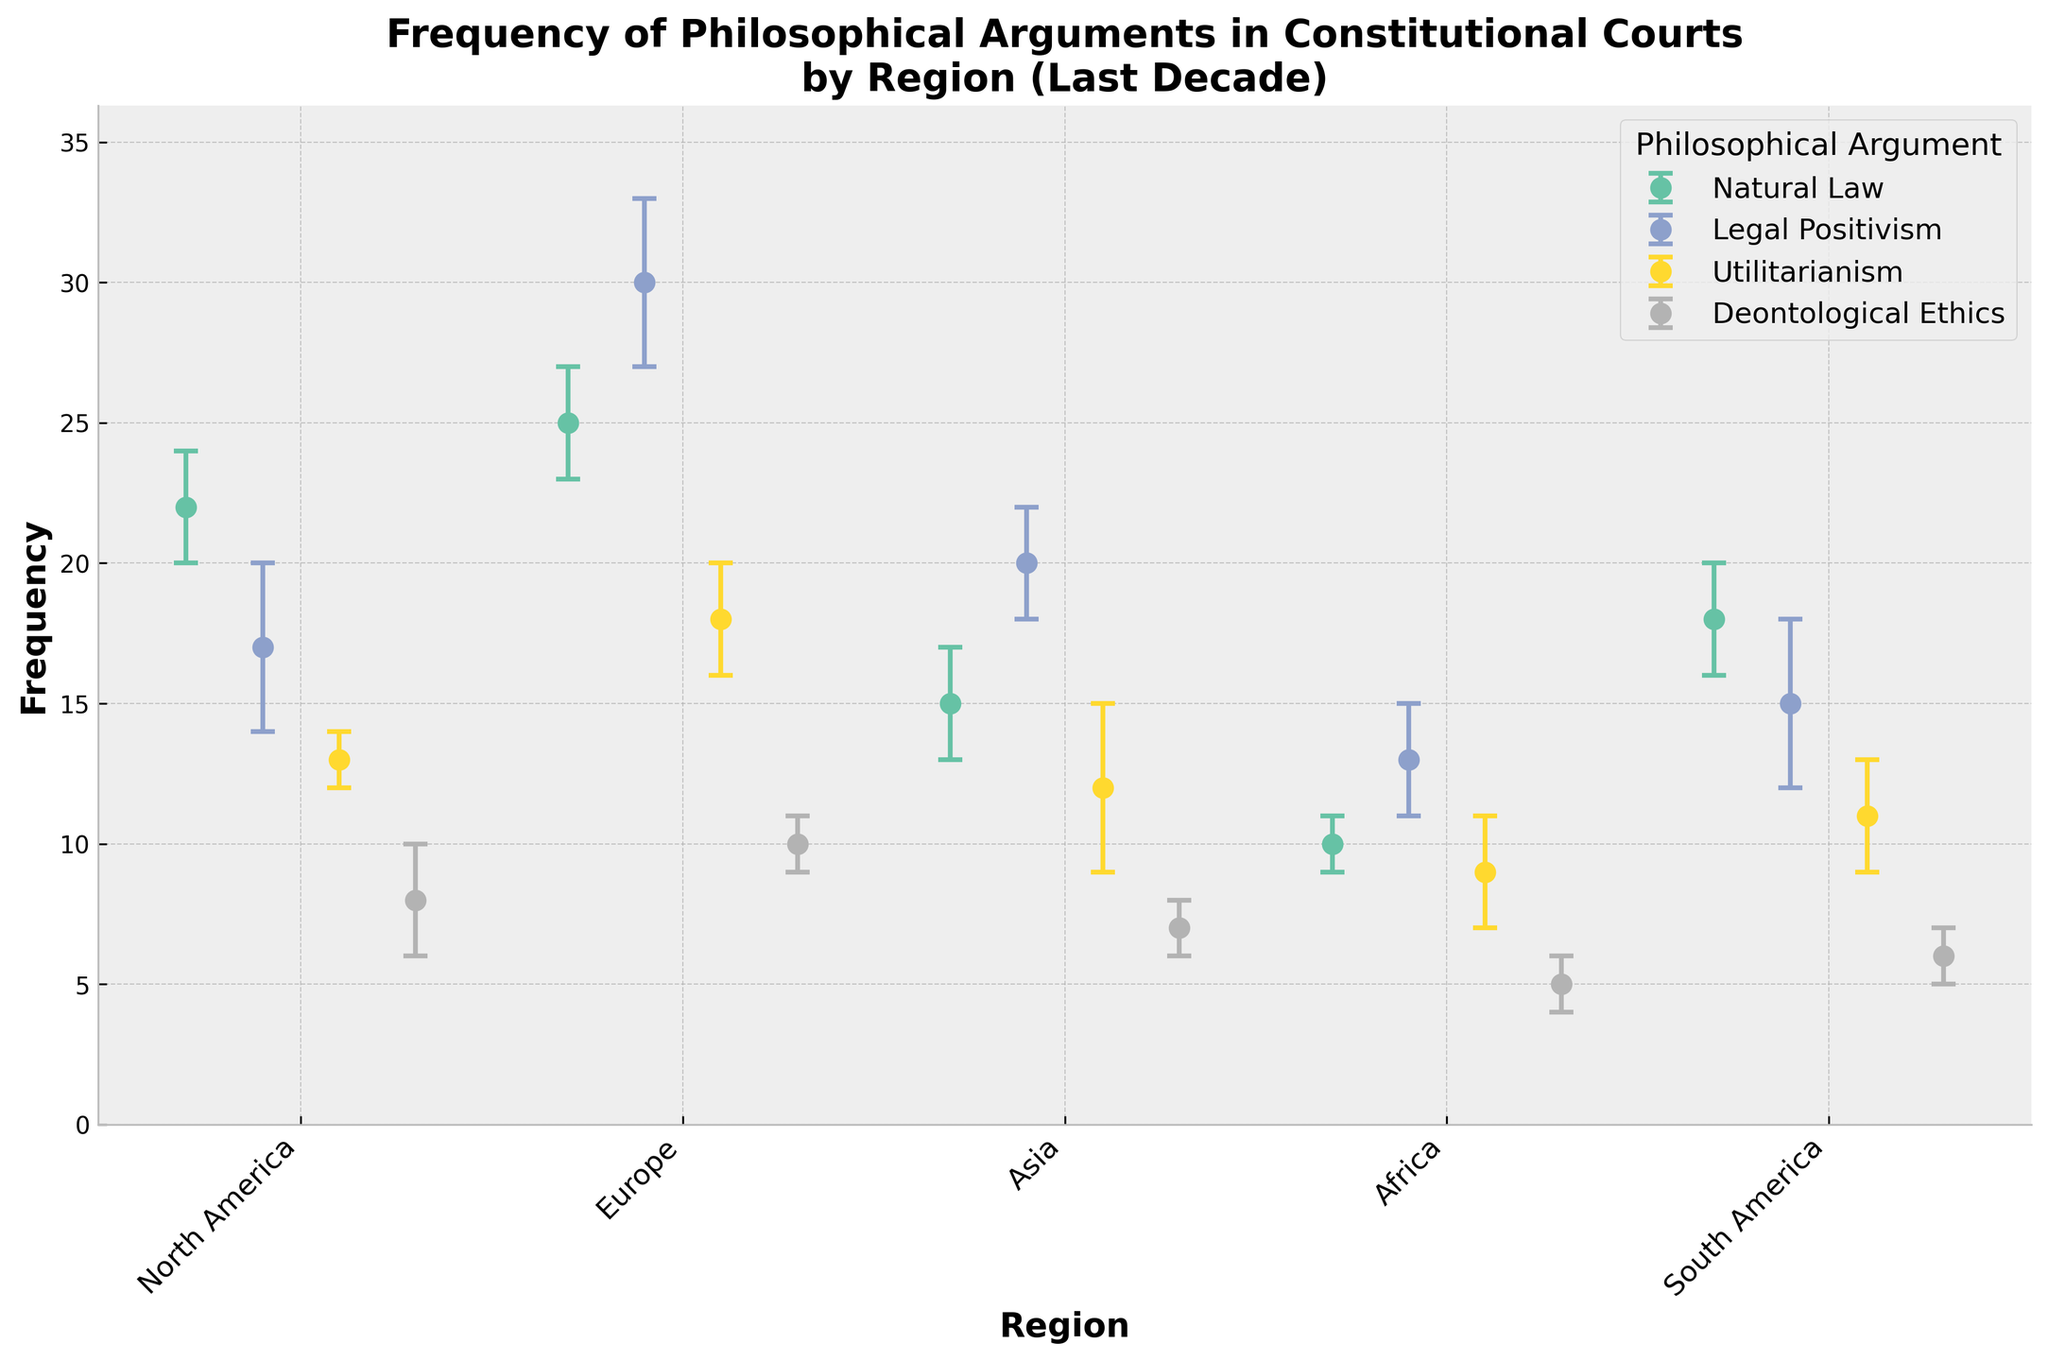What is the title of the figure? At the top of the figure, there is a text that summarizes the content of the plot. The title is "Frequency of Philosophical Arguments in Constitutional Courts by Region (Last Decade)."
Answer: Frequency of Philosophical Arguments in Constitutional Courts by Region (Last Decade) Which philosophical argument is most frequently used in Europe? By observing the height of the dots for Europe, the argument with the highest frequency value is identified. "Legal Positivism" has the highest frequency value among other arguments in Europe.
Answer: Legal Positivism What is the frequency of Utilitarianism in North America? By locating the dot for Utilitarianism in the region of North America, the associated frequency value is read off from the plot. The frequency of Utilitarianism in North America is indicated by dot placement at 13.
Answer: 13 Which region has the least frequency of Deontological Ethics? By examining the dots for Deontological Ethics across all regions, the region with the lowest dot is identified. The dot for Deontological Ethics in Africa is the lowest, indicating a frequency of 5.
Answer: Africa What is the total frequency of Legal Positivism across all regions? Sum the frequency values for Legal Positivism in each region: North America (17) + Europe (30) + Asia (20) + Africa (13) + South America (15). The total frequency is calculated as 95.
Answer: 95 Compare the frequency of Natural Law between North America and South America. Which region has a higher frequency? By looking at the dots for Natural Law in both North America (22) and South America (18), the higher of the two values is identified. North America's dot is positioned higher, indicating a higher frequency.
Answer: North America What is the average error margin for Utilitarianism across all regions? Add the error margins for Utilitarianism from all regions (North America, Europe, Asia, Africa, South America) and divide by the number of regions (5): (1 + 2 + 3 + 2 + 2) / 5. The average error margin is calculated as 2.
Answer: 2 Which philosophical argument and region combination has the largest error margin? By observing the error bars (vertical lines) associated with each dot, identifying the argument and region with the longest error bar. Legal Positivism in North America has the largest error margin of 3.
Answer: Legal Positivism in North America What is the sum of the frequencies of arguments in South America? Sum the frequency values for all arguments in South America: Natural Law (18) + Legal Positivism (15) + Utilitarianism (11) + Deontological Ethics (6). The total sum of the frequencies is 50.
Answer: 50 How does the frequency of Natural Law in Asia compare to Legal Positivism in the same region? Compare the frequency values for Natural Law (15) and Legal Positivism (20) in Asia. Legal Positivism's dot is positioned higher than that of Natural Law, indicating a higher frequency for Legal Positivism.
Answer: Legal Positivism is higher 